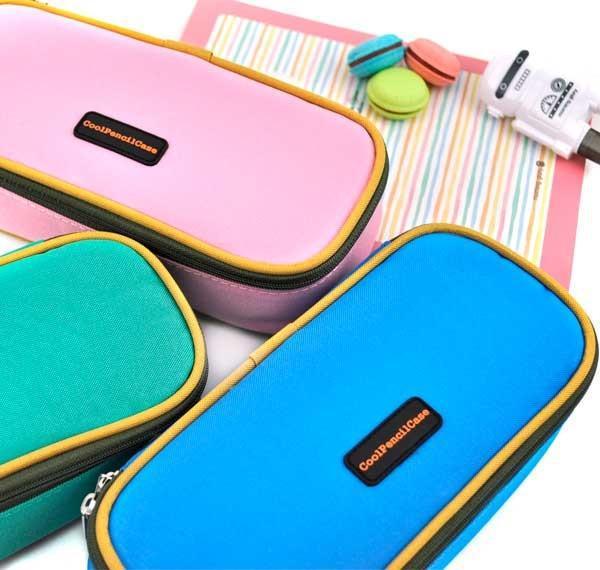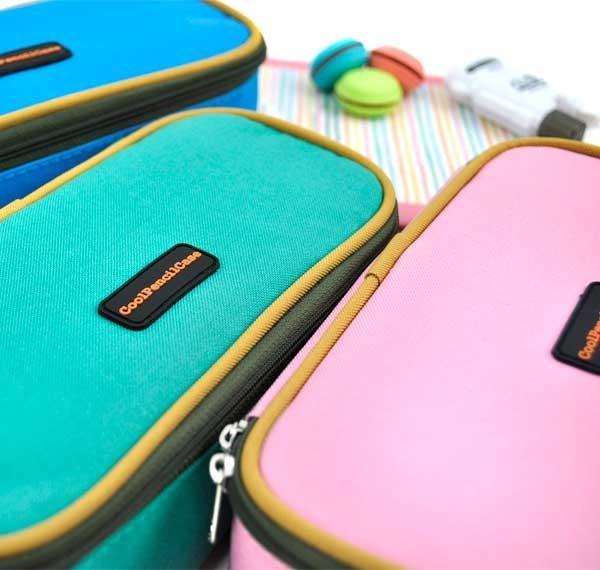The first image is the image on the left, the second image is the image on the right. For the images shown, is this caption "No image shows a pencil case that is opened." true? Answer yes or no. Yes. The first image is the image on the left, the second image is the image on the right. Examine the images to the left and right. Is the description "One of the cases in the image on the right is open." accurate? Answer yes or no. No. 